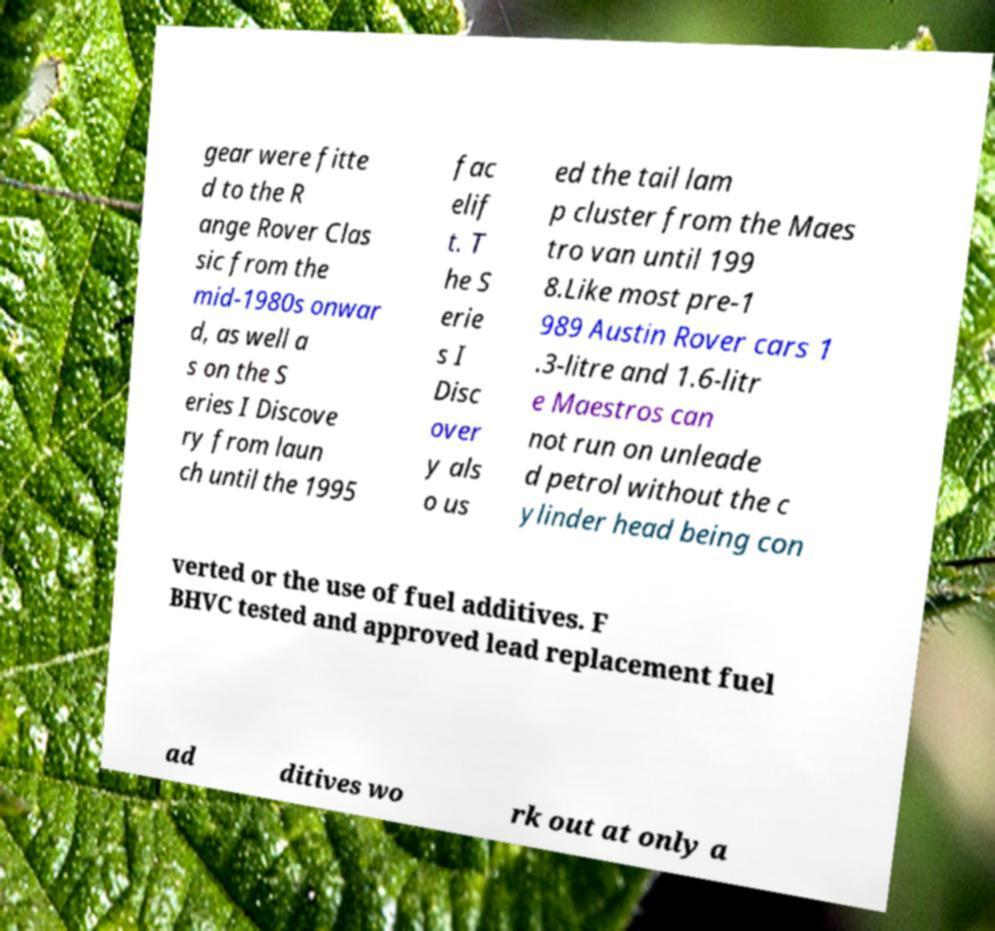What messages or text are displayed in this image? I need them in a readable, typed format. gear were fitte d to the R ange Rover Clas sic from the mid-1980s onwar d, as well a s on the S eries I Discove ry from laun ch until the 1995 fac elif t. T he S erie s I Disc over y als o us ed the tail lam p cluster from the Maes tro van until 199 8.Like most pre-1 989 Austin Rover cars 1 .3-litre and 1.6-litr e Maestros can not run on unleade d petrol without the c ylinder head being con verted or the use of fuel additives. F BHVC tested and approved lead replacement fuel ad ditives wo rk out at only a 